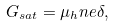<formula> <loc_0><loc_0><loc_500><loc_500>G _ { s a t } = \mu _ { h } n e \delta ,</formula> 